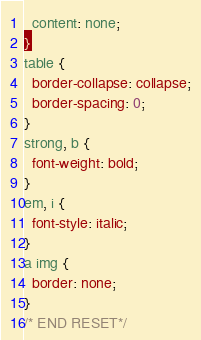Convert code to text. <code><loc_0><loc_0><loc_500><loc_500><_CSS_>  content: none;
}
table {
  border-collapse: collapse;
  border-spacing: 0;
}
strong, b {
  font-weight: bold;
}
em, i {
  font-style: italic;
}
a img {
  border: none;
}
/* END RESET*/</code> 